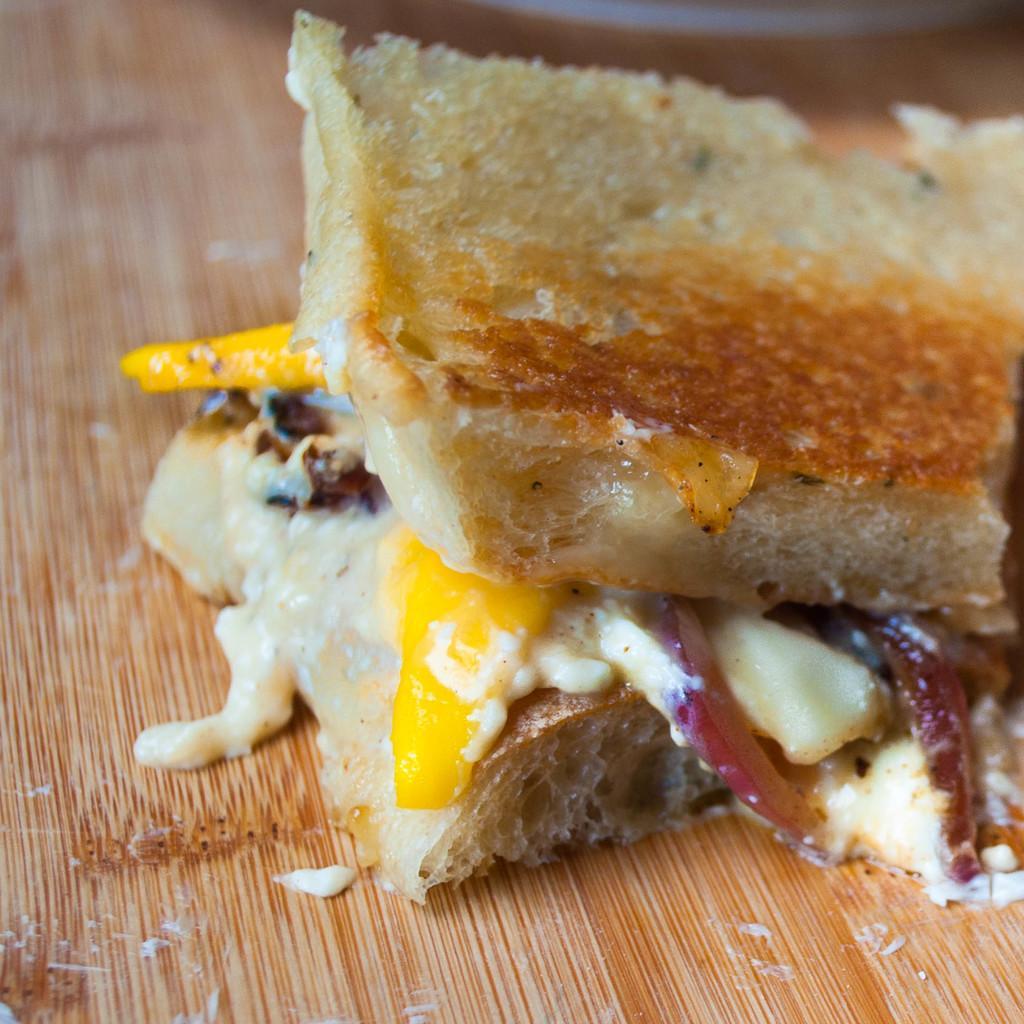How would you summarize this image in a sentence or two? In this picture I can see a food item on the wooden surface. 